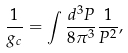Convert formula to latex. <formula><loc_0><loc_0><loc_500><loc_500>\frac { 1 } { g _ { c } } = \int \frac { d ^ { 3 } P } { 8 \pi ^ { 3 } } \frac { 1 } { P ^ { 2 } } ,</formula> 